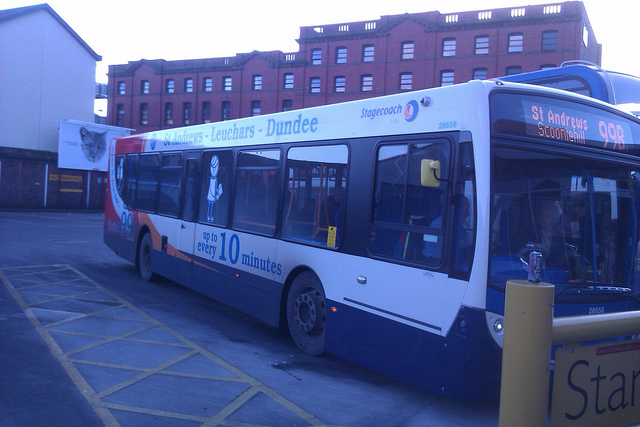Please transcribe the text in this image. 10 minutes Stagecoach Dundee Leuchars Star scooniehill 998 Andrews St 99 every to St Andrews 